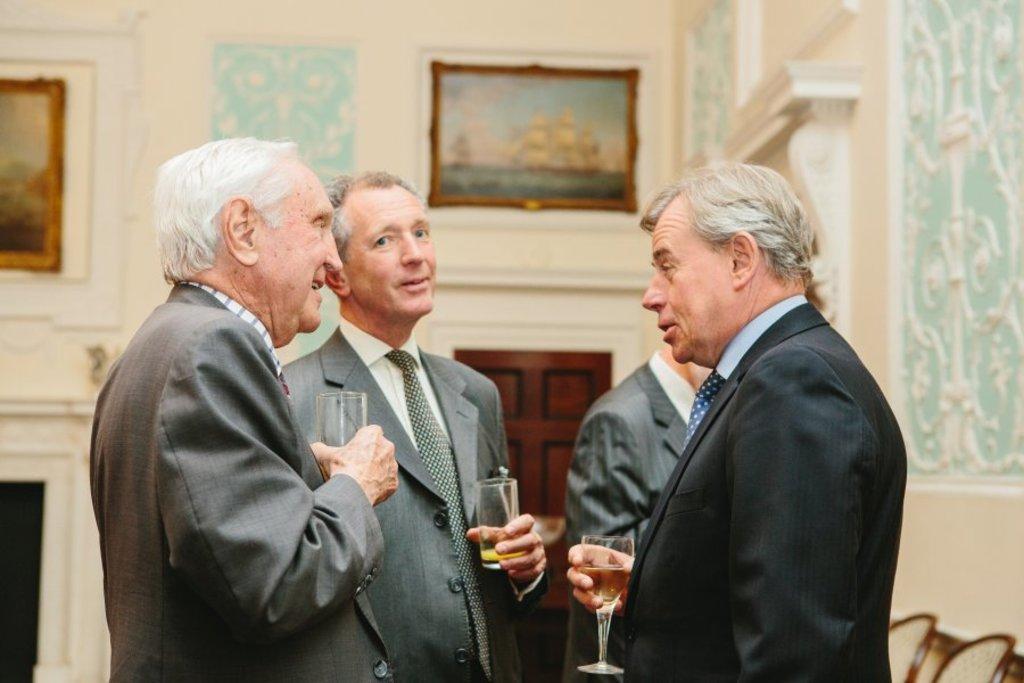In one or two sentences, can you explain what this image depicts? In this image we can see these people wearing blazers are standing and holding glasses with drinks in it. The background of the image is slightly blurred, where we can see photo frames on the wall and wooden door here. 